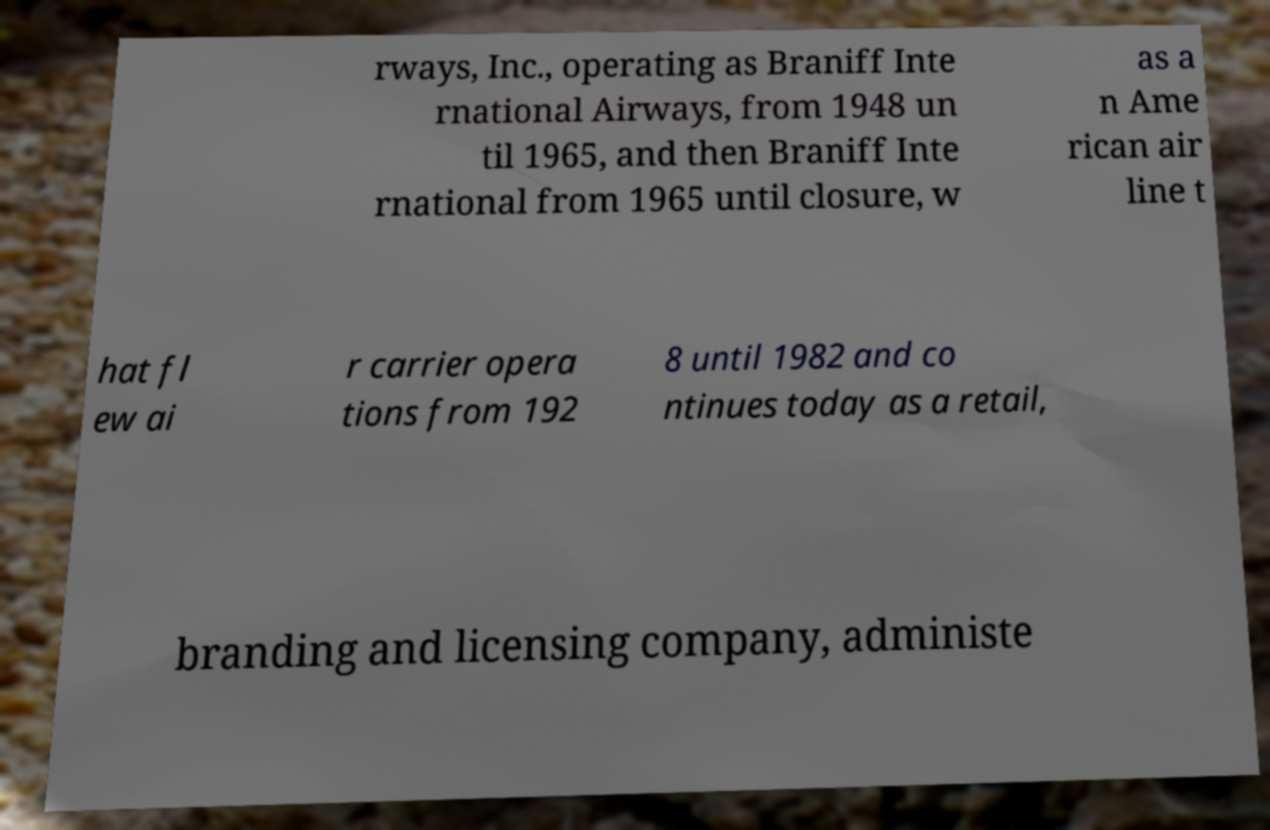Can you accurately transcribe the text from the provided image for me? rways, Inc., operating as Braniff Inte rnational Airways, from 1948 un til 1965, and then Braniff Inte rnational from 1965 until closure, w as a n Ame rican air line t hat fl ew ai r carrier opera tions from 192 8 until 1982 and co ntinues today as a retail, branding and licensing company, administe 